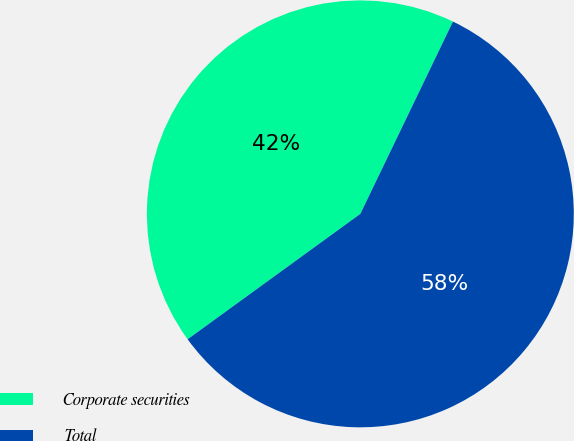Convert chart to OTSL. <chart><loc_0><loc_0><loc_500><loc_500><pie_chart><fcel>Corporate securities<fcel>Total<nl><fcel>42.14%<fcel>57.86%<nl></chart> 